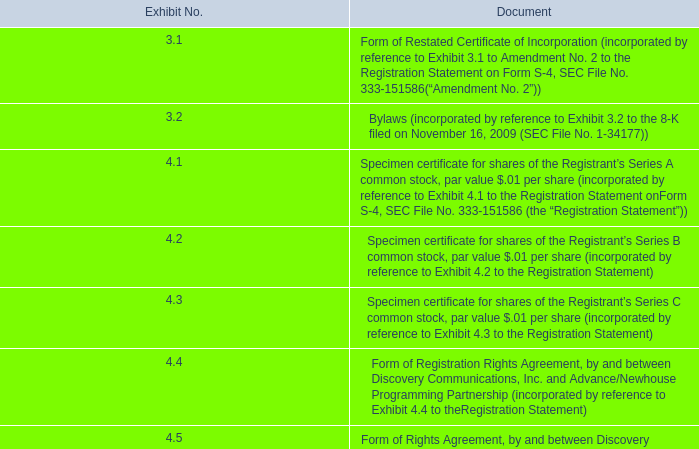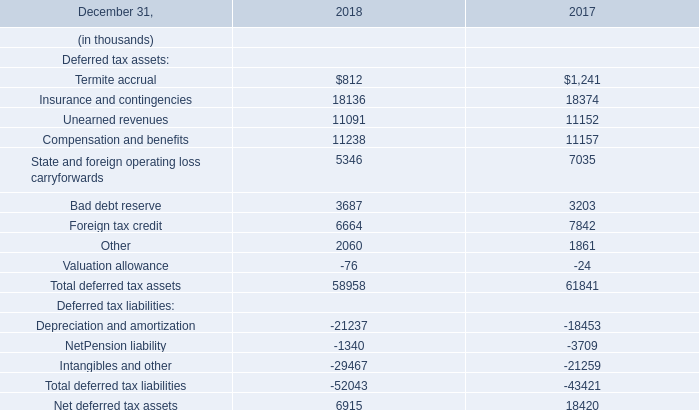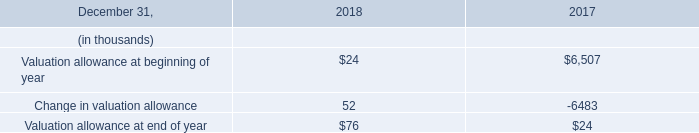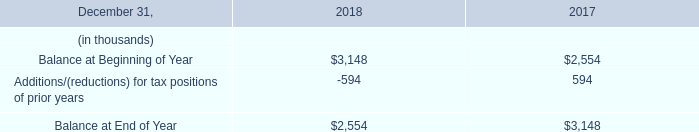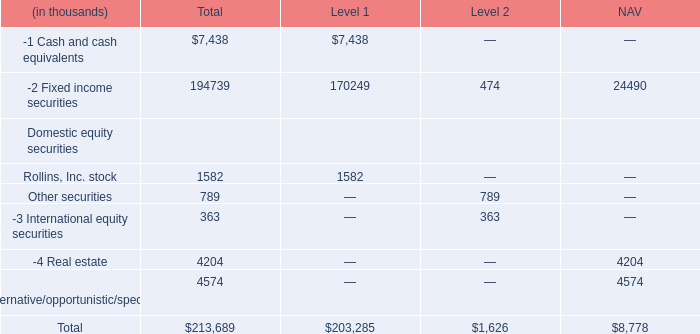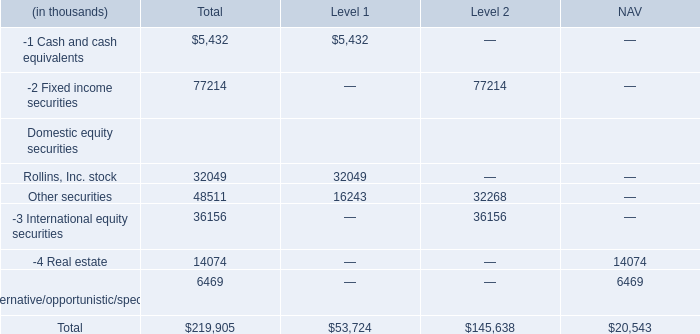What is the sum of Rollins, Inc. stock for Level 1 and Unearned revenues in 2017? (in thousand) 
Computations: (1582 + 11152)
Answer: 12734.0. 